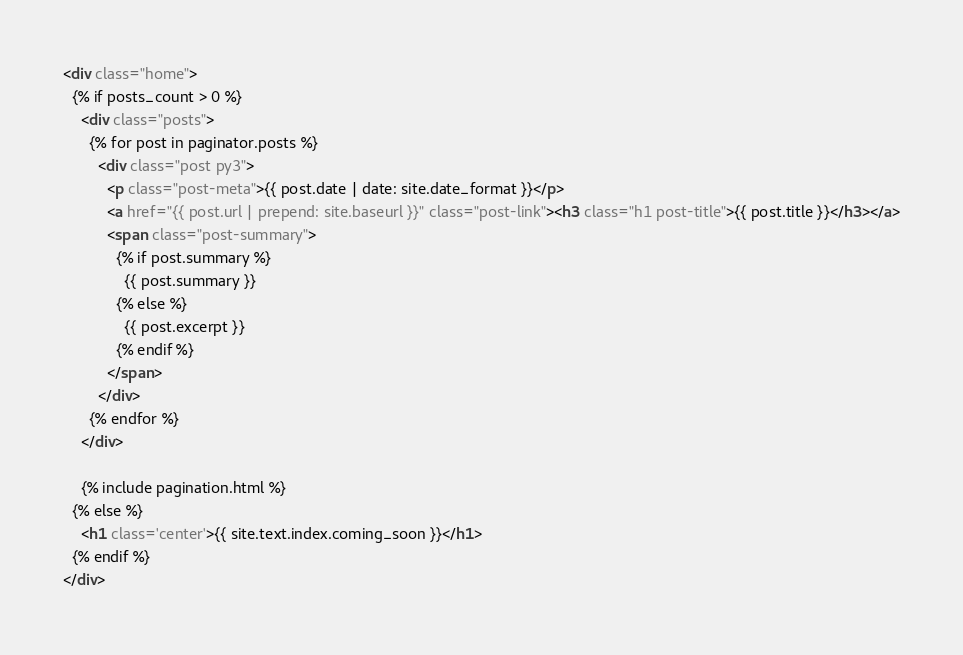<code> <loc_0><loc_0><loc_500><loc_500><_HTML_><div class="home">
  {% if posts_count > 0 %}
    <div class="posts">
      {% for post in paginator.posts %}
        <div class="post py3">
          <p class="post-meta">{{ post.date | date: site.date_format }}</p>
          <a href="{{ post.url | prepend: site.baseurl }}" class="post-link"><h3 class="h1 post-title">{{ post.title }}</h3></a>
          <span class="post-summary">
            {% if post.summary %}
              {{ post.summary }}
            {% else %}
              {{ post.excerpt }}
            {% endif %}
          </span>
        </div>
      {% endfor %}
    </div> 

    {% include pagination.html %}
  {% else %}
    <h1 class='center'>{{ site.text.index.coming_soon }}</h1>
  {% endif %}
</div>
</code> 